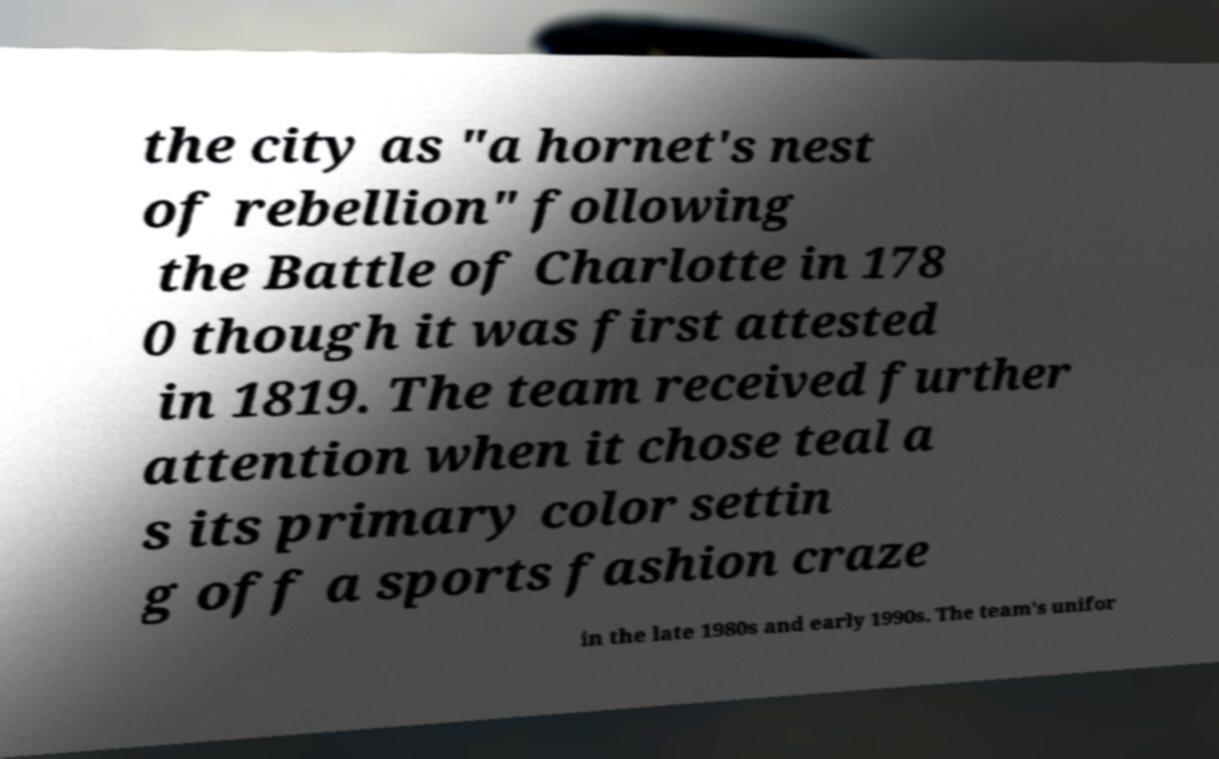Can you accurately transcribe the text from the provided image for me? the city as "a hornet's nest of rebellion" following the Battle of Charlotte in 178 0 though it was first attested in 1819. The team received further attention when it chose teal a s its primary color settin g off a sports fashion craze in the late 1980s and early 1990s. The team's unifor 